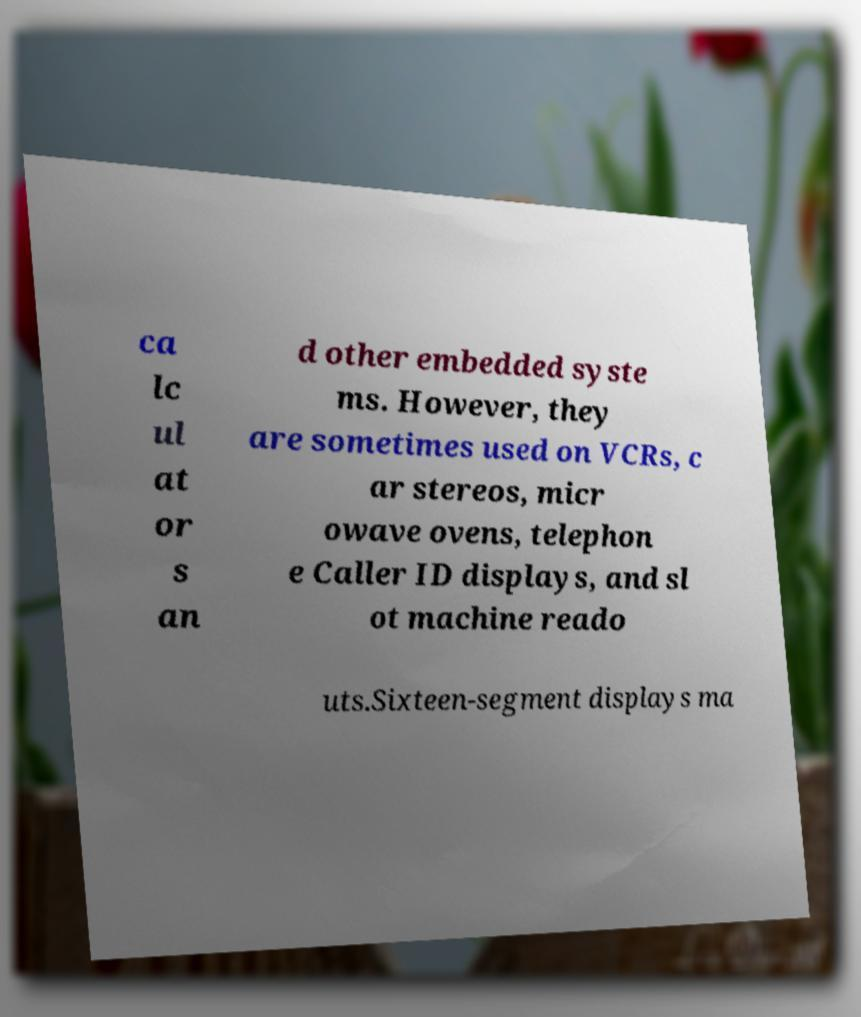I need the written content from this picture converted into text. Can you do that? ca lc ul at or s an d other embedded syste ms. However, they are sometimes used on VCRs, c ar stereos, micr owave ovens, telephon e Caller ID displays, and sl ot machine reado uts.Sixteen-segment displays ma 